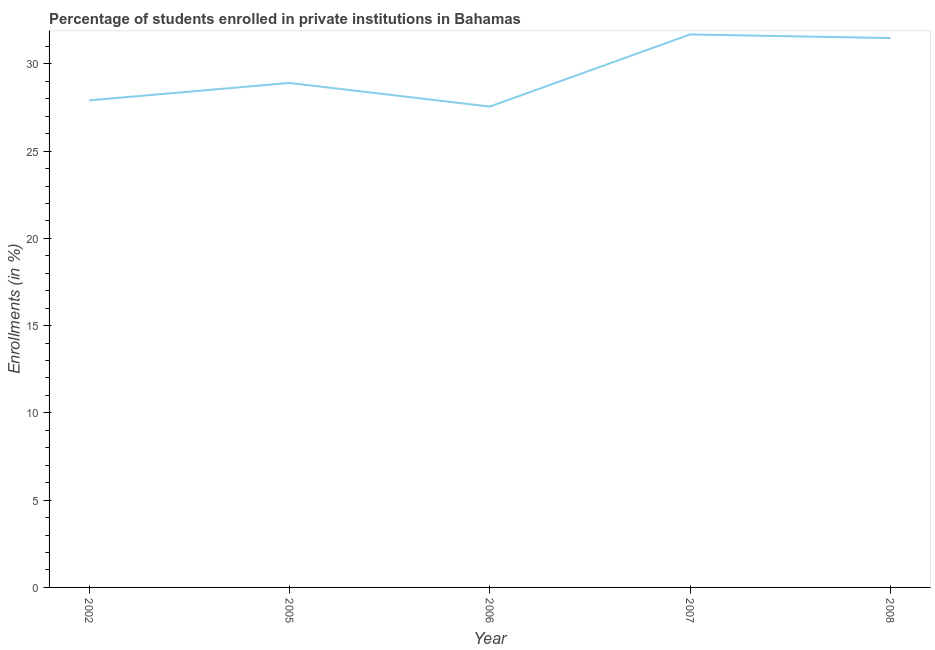What is the enrollments in private institutions in 2005?
Ensure brevity in your answer.  28.91. Across all years, what is the maximum enrollments in private institutions?
Your answer should be compact. 31.69. Across all years, what is the minimum enrollments in private institutions?
Provide a succinct answer. 27.55. In which year was the enrollments in private institutions minimum?
Your answer should be very brief. 2006. What is the sum of the enrollments in private institutions?
Offer a very short reply. 147.53. What is the difference between the enrollments in private institutions in 2006 and 2007?
Make the answer very short. -4.13. What is the average enrollments in private institutions per year?
Give a very brief answer. 29.51. What is the median enrollments in private institutions?
Ensure brevity in your answer.  28.91. Do a majority of the years between 2006 and 2008 (inclusive) have enrollments in private institutions greater than 26 %?
Give a very brief answer. Yes. What is the ratio of the enrollments in private institutions in 2002 to that in 2008?
Keep it short and to the point. 0.89. Is the enrollments in private institutions in 2002 less than that in 2007?
Offer a very short reply. Yes. Is the difference between the enrollments in private institutions in 2005 and 2006 greater than the difference between any two years?
Your answer should be very brief. No. What is the difference between the highest and the second highest enrollments in private institutions?
Provide a short and direct response. 0.21. Is the sum of the enrollments in private institutions in 2002 and 2006 greater than the maximum enrollments in private institutions across all years?
Offer a very short reply. Yes. What is the difference between the highest and the lowest enrollments in private institutions?
Your answer should be very brief. 4.13. In how many years, is the enrollments in private institutions greater than the average enrollments in private institutions taken over all years?
Your answer should be compact. 2. Does the enrollments in private institutions monotonically increase over the years?
Your answer should be compact. No. What is the difference between two consecutive major ticks on the Y-axis?
Your response must be concise. 5. What is the title of the graph?
Make the answer very short. Percentage of students enrolled in private institutions in Bahamas. What is the label or title of the Y-axis?
Ensure brevity in your answer.  Enrollments (in %). What is the Enrollments (in %) of 2002?
Ensure brevity in your answer.  27.91. What is the Enrollments (in %) in 2005?
Keep it short and to the point. 28.91. What is the Enrollments (in %) in 2006?
Offer a very short reply. 27.55. What is the Enrollments (in %) of 2007?
Offer a very short reply. 31.69. What is the Enrollments (in %) of 2008?
Offer a terse response. 31.48. What is the difference between the Enrollments (in %) in 2002 and 2005?
Offer a terse response. -1. What is the difference between the Enrollments (in %) in 2002 and 2006?
Offer a very short reply. 0.35. What is the difference between the Enrollments (in %) in 2002 and 2007?
Provide a succinct answer. -3.78. What is the difference between the Enrollments (in %) in 2002 and 2008?
Your response must be concise. -3.57. What is the difference between the Enrollments (in %) in 2005 and 2006?
Provide a succinct answer. 1.36. What is the difference between the Enrollments (in %) in 2005 and 2007?
Provide a succinct answer. -2.78. What is the difference between the Enrollments (in %) in 2005 and 2008?
Give a very brief answer. -2.57. What is the difference between the Enrollments (in %) in 2006 and 2007?
Your answer should be compact. -4.13. What is the difference between the Enrollments (in %) in 2006 and 2008?
Provide a succinct answer. -3.93. What is the difference between the Enrollments (in %) in 2007 and 2008?
Ensure brevity in your answer.  0.21. What is the ratio of the Enrollments (in %) in 2002 to that in 2006?
Your response must be concise. 1.01. What is the ratio of the Enrollments (in %) in 2002 to that in 2007?
Give a very brief answer. 0.88. What is the ratio of the Enrollments (in %) in 2002 to that in 2008?
Your answer should be compact. 0.89. What is the ratio of the Enrollments (in %) in 2005 to that in 2006?
Your response must be concise. 1.05. What is the ratio of the Enrollments (in %) in 2005 to that in 2007?
Keep it short and to the point. 0.91. What is the ratio of the Enrollments (in %) in 2005 to that in 2008?
Give a very brief answer. 0.92. What is the ratio of the Enrollments (in %) in 2006 to that in 2007?
Make the answer very short. 0.87. 